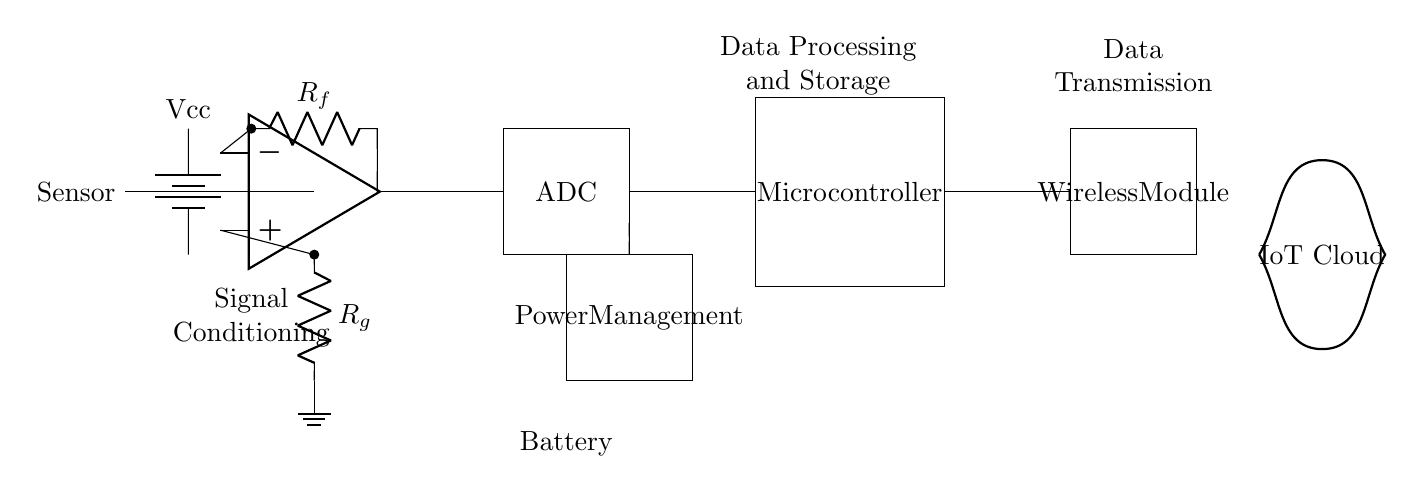What is the main function of the amplifier? The amplifier's main function is to increase the signal strength from the sensor, allowing for improved processing by subsequent components.
Answer: Increase signal strength What is the role of the ADC in the circuit? The ADC converts the analog signal output from the amplifier into a digital signal for processing in the microcontroller, enabling data storage and transmission.
Answer: Convert analog to digital What type of power source is shown in the circuit? The circuit features a battery as the power source, as indicated by the battery symbol near the signal conditioning section.
Answer: Battery What component handles data transmission in this circuit? The wireless module is responsible for transmitting processed data from the microcontroller to the IoT cloud for further utilization.
Answer: Wireless module What does the term "signal conditioning" refer to in this circuit? Signal conditioning refers to the operational processes that enhance the sensor's output, usually through amplification, filtering, and conversion, before it is processed further.
Answer: Enhancing sensor output How many main sections are present in the circuit? The circuit consists of five main sections: Sensor, Signal Conditioning, Data Processing, Power Management, and Data Transmission.
Answer: Five What is the purpose of the power management component? Power management is responsible for regulating the voltage and current supplied to the circuit components, ensuring efficient and safe operation.
Answer: Regulate voltage and current 